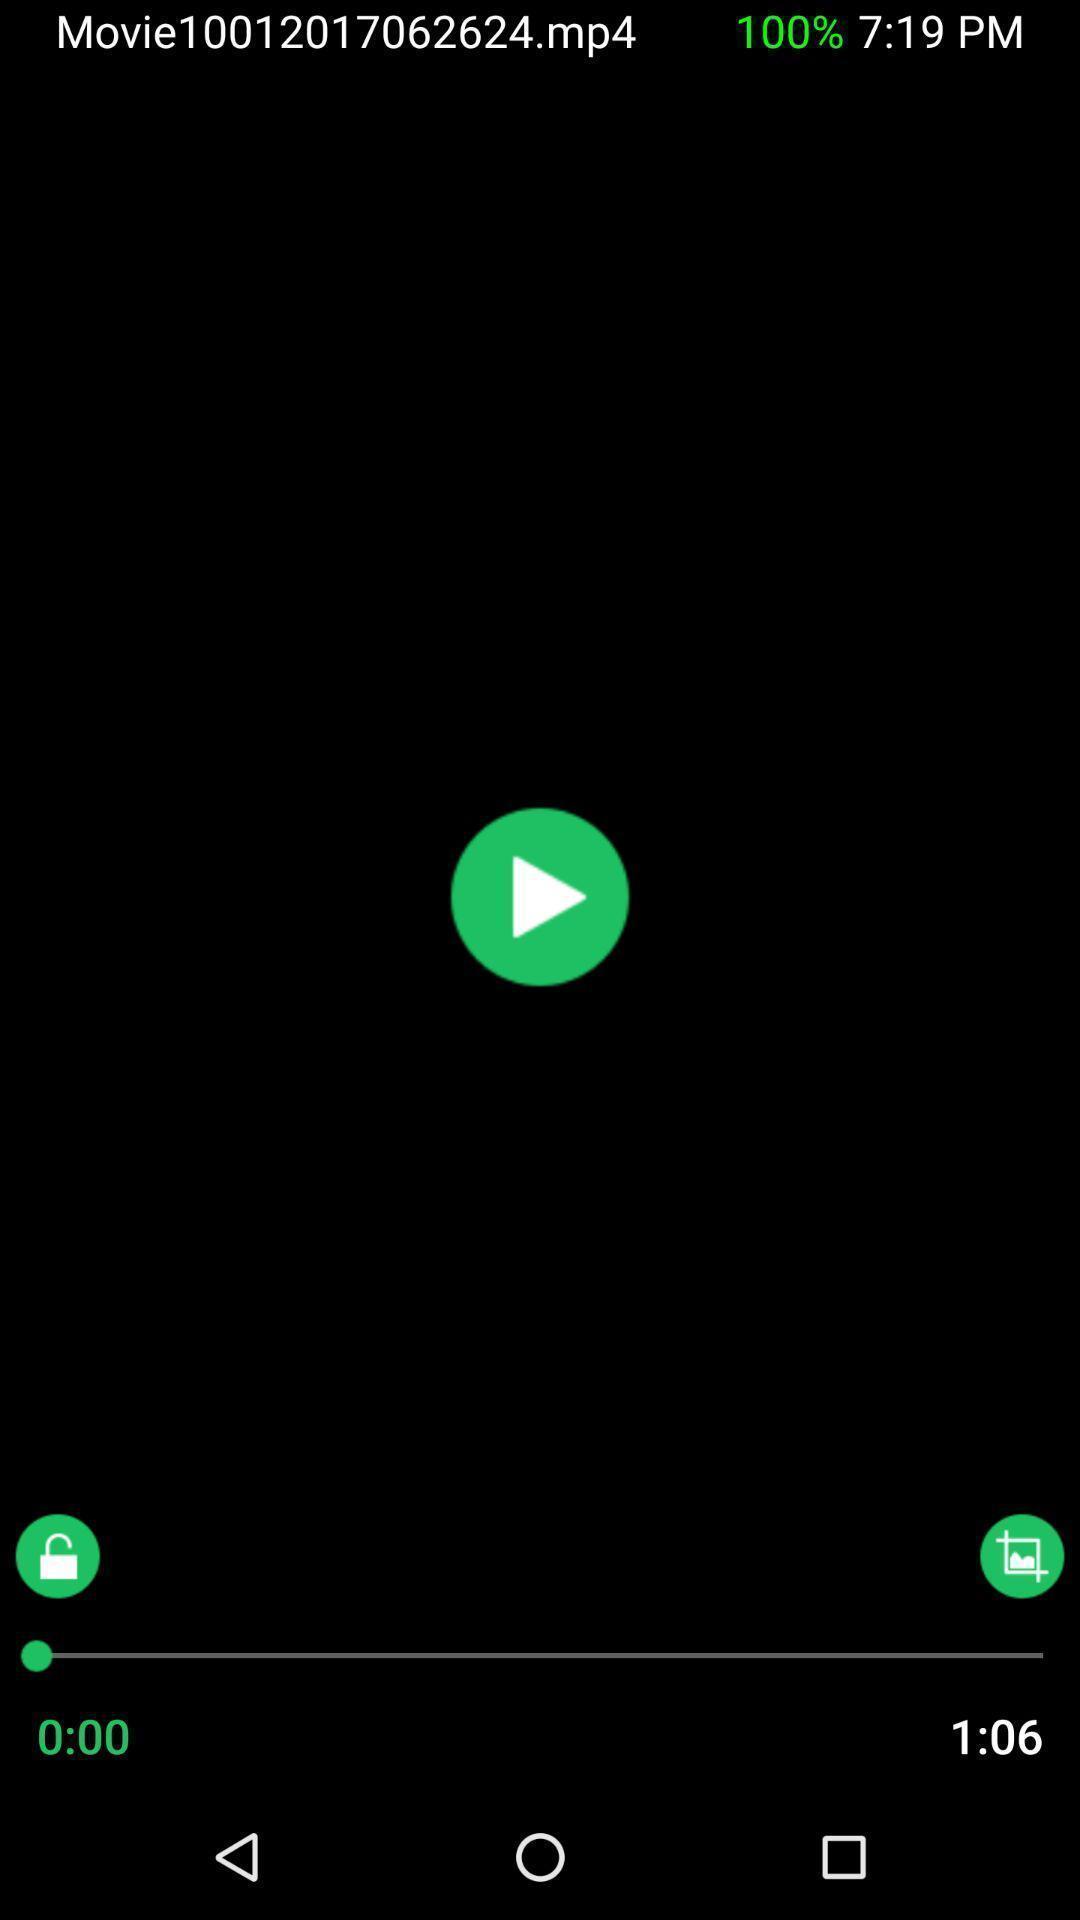What is the overall content of this screenshot? Screen shows video of movie. 